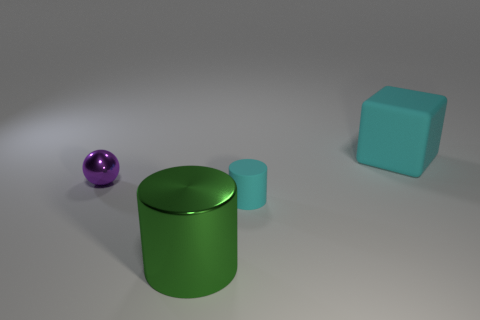What color is the big thing on the right side of the cylinder that is behind the large green thing?
Keep it short and to the point. Cyan. What number of spheres have the same color as the rubber block?
Provide a short and direct response. 0. Is the color of the big cylinder the same as the cylinder that is right of the green shiny cylinder?
Make the answer very short. No. Are there fewer tiny red cubes than tiny cyan things?
Your answer should be very brief. Yes. Is the number of cyan objects that are left of the small cyan object greater than the number of cyan things that are to the left of the cyan matte cube?
Ensure brevity in your answer.  No. Does the large cylinder have the same material as the big cyan object?
Your answer should be very brief. No. What number of cyan matte objects are in front of the object to the right of the small cyan rubber cylinder?
Give a very brief answer. 1. Do the large metal thing that is in front of the small purple object and the tiny matte thing have the same color?
Keep it short and to the point. No. How many objects are either large cyan shiny objects or objects on the left side of the large cyan block?
Offer a very short reply. 3. Do the metallic thing that is left of the metallic cylinder and the tiny object that is to the right of the big green cylinder have the same shape?
Offer a very short reply. No. 